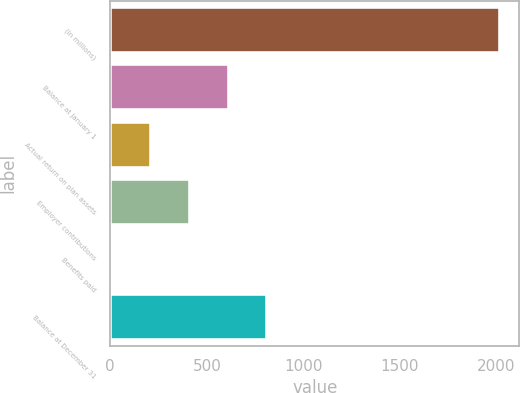<chart> <loc_0><loc_0><loc_500><loc_500><bar_chart><fcel>(in millions)<fcel>Balance at January 1<fcel>Actual return on plan assets<fcel>Employer contributions<fcel>Benefits paid<fcel>Balance at December 31<nl><fcel>2017<fcel>612.52<fcel>211.24<fcel>411.88<fcel>10.6<fcel>813.16<nl></chart> 